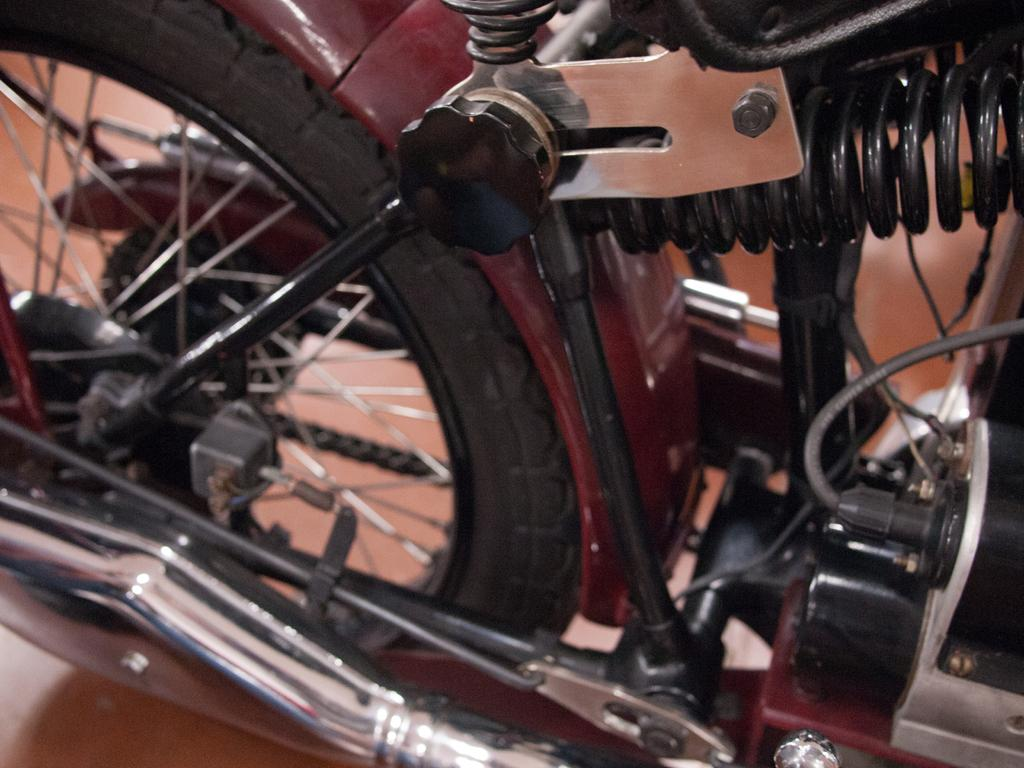What is the main object in the image? There is a bike in the image. What part of the bike is mentioned in the facts? The bike has a tire. What surface is the bike placed on? There is a floor visible in the image. What type of apparel is the kitty wearing in the image? There is no kitty present in the image, and therefore no apparel can be observed. 